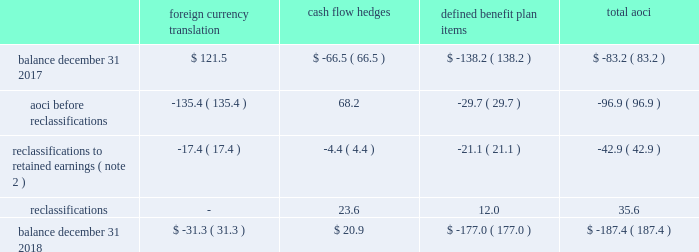Zimmer biomet holdings , inc .
And subsidiaries 2018 form 10-k annual report notes to consolidated financial statements ( continued ) default for unsecured financing arrangements , including , among other things , limitations on consolidations , mergers and sales of assets .
Financial covenants under the 2018 , 2016 and 2014 credit agreements include a consolidated indebtedness to consolidated ebitda ratio of no greater than 5.0 to 1.0 through june 30 , 2017 , and no greater than 4.5 to 1.0 thereafter .
If our credit rating falls below investment grade , additional restrictions would result , including restrictions on investments and payment of dividends .
We were in compliance with all covenants under the 2018 , 2016 and 2014 credit agreements as of december 31 , 2018 .
As of december 31 , 2018 , there were no borrowings outstanding under the multicurrency revolving facility .
We may , at our option , redeem our senior notes , in whole or in part , at any time upon payment of the principal , any applicable make-whole premium , and accrued and unpaid interest to the date of redemption , except that the floating rate notes due 2021 may not be redeemed until on or after march 20 , 2019 and such notes do not have any applicable make-whole premium .
In addition , we may redeem , at our option , the 2.700% ( 2.700 % ) senior notes due 2020 , the 3.375% ( 3.375 % ) senior notes due 2021 , the 3.150% ( 3.150 % ) senior notes due 2022 , the 3.700% ( 3.700 % ) senior notes due 2023 , the 3.550% ( 3.550 % ) senior notes due 2025 , the 4.250% ( 4.250 % ) senior notes due 2035 and the 4.450% ( 4.450 % ) senior notes due 2045 without any make-whole premium at specified dates ranging from one month to six months in advance of the scheduled maturity date .
The estimated fair value of our senior notes as of december 31 , 2018 , based on quoted prices for the specific securities from transactions in over-the-counter markets ( level 2 ) , was $ 7798.9 million .
The estimated fair value of japan term loan a and japan term loan b , in the aggregate , as of december 31 , 2018 , based upon publicly available market yield curves and the terms of the debt ( level 2 ) , was $ 294.7 million .
The carrying values of u.s .
Term loan b and u.s .
Term loan c approximate fair value as they bear interest at short-term variable market rates .
We entered into interest rate swap agreements which we designated as fair value hedges of underlying fixed-rate obligations on our senior notes due 2019 and 2021 .
These fair value hedges were settled in 2016 .
In 2016 , we entered into various variable-to-fixed interest rate swap agreements that were accounted for as cash flow hedges of u.s .
Term loan b .
In 2018 , we entered into cross-currency interest rate swaps that we designated as net investment hedges .
The excluded component of these net investment hedges is recorded in interest expense , net .
See note 13 for additional information regarding our interest rate swap agreements .
We also have available uncommitted credit facilities totaling $ 55.0 million .
At december 31 , 2018 and 2017 , the weighted average interest rate for our borrowings was 3.1 percent and 2.9 percent , respectively .
We paid $ 282.8 million , $ 317.5 million , and $ 363.1 million in interest during 2018 , 2017 , and 2016 , respectively .
12 .
Accumulated other comprehensive ( loss ) income aoci refers to certain gains and losses that under gaap are included in comprehensive income but are excluded from net earnings as these amounts are initially recorded as an adjustment to stockholders 2019 equity .
Amounts in aoci may be reclassified to net earnings upon the occurrence of certain events .
Our aoci is comprised of foreign currency translation adjustments , including unrealized gains and losses on net investment hedges , unrealized gains and losses on cash flow hedges , and amortization of prior service costs and unrecognized gains and losses in actuarial assumptions on our defined benefit plans .
Foreign currency translation adjustments are reclassified to net earnings upon sale or upon a complete or substantially complete liquidation of an investment in a foreign entity .
Unrealized gains and losses on cash flow hedges are reclassified to net earnings when the hedged item affects net earnings .
Amounts related to defined benefit plans that are in aoci are reclassified over the service periods of employees in the plan .
See note 14 for more information on our defined benefit plans .
The table shows the changes in the components of aoci , net of tax ( in millions ) : foreign currency translation hedges defined benefit plan items .

What percentage of aoci at december 31 , 2018 is attributed to foreign currency translation? 
Computations: (-31.3 / -187.4)
Answer: 0.16702. 